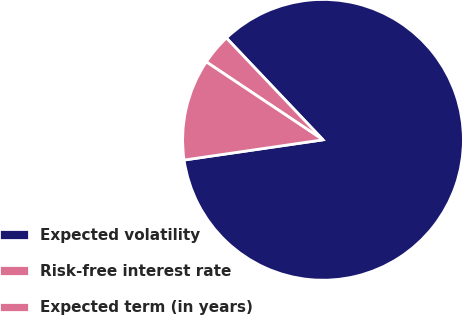<chart> <loc_0><loc_0><loc_500><loc_500><pie_chart><fcel>Expected volatility<fcel>Risk-free interest rate<fcel>Expected term (in years)<nl><fcel>84.78%<fcel>3.55%<fcel>11.67%<nl></chart> 